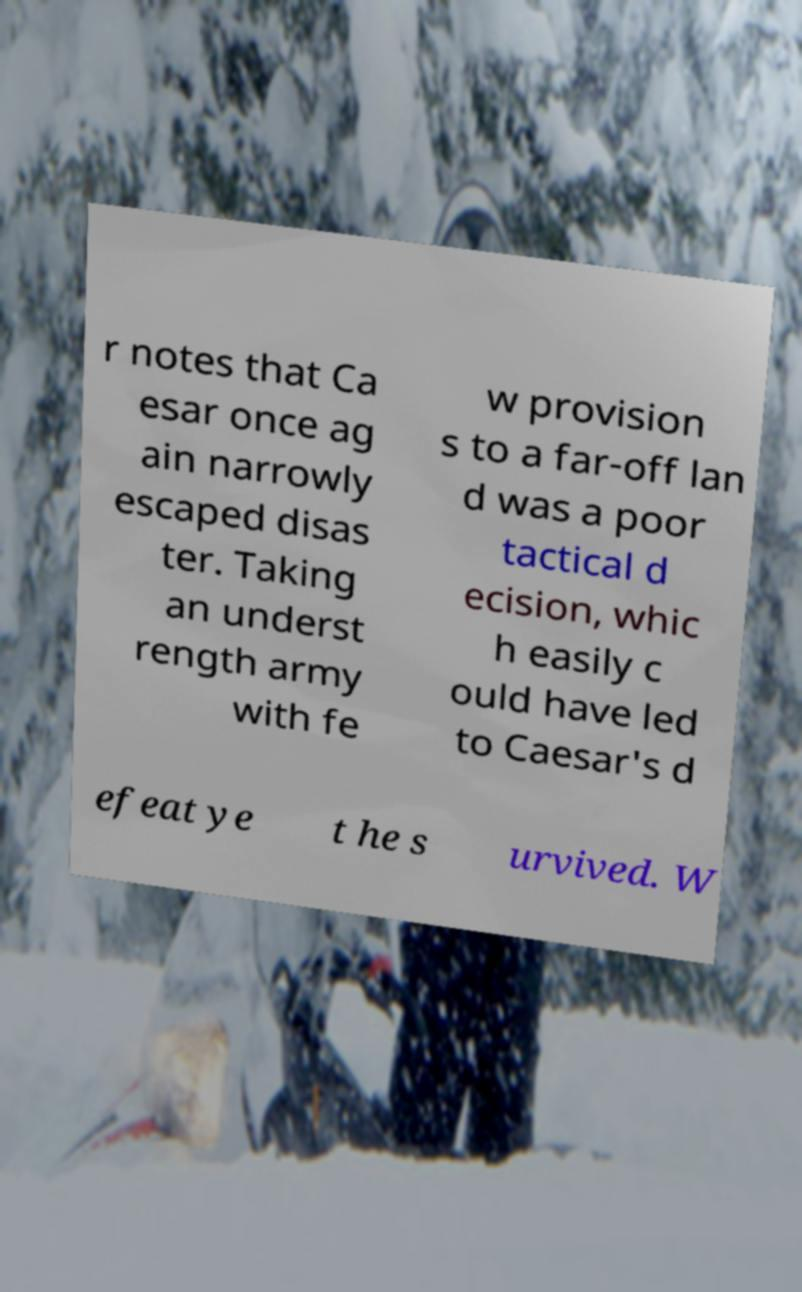For documentation purposes, I need the text within this image transcribed. Could you provide that? r notes that Ca esar once ag ain narrowly escaped disas ter. Taking an underst rength army with fe w provision s to a far-off lan d was a poor tactical d ecision, whic h easily c ould have led to Caesar's d efeat ye t he s urvived. W 